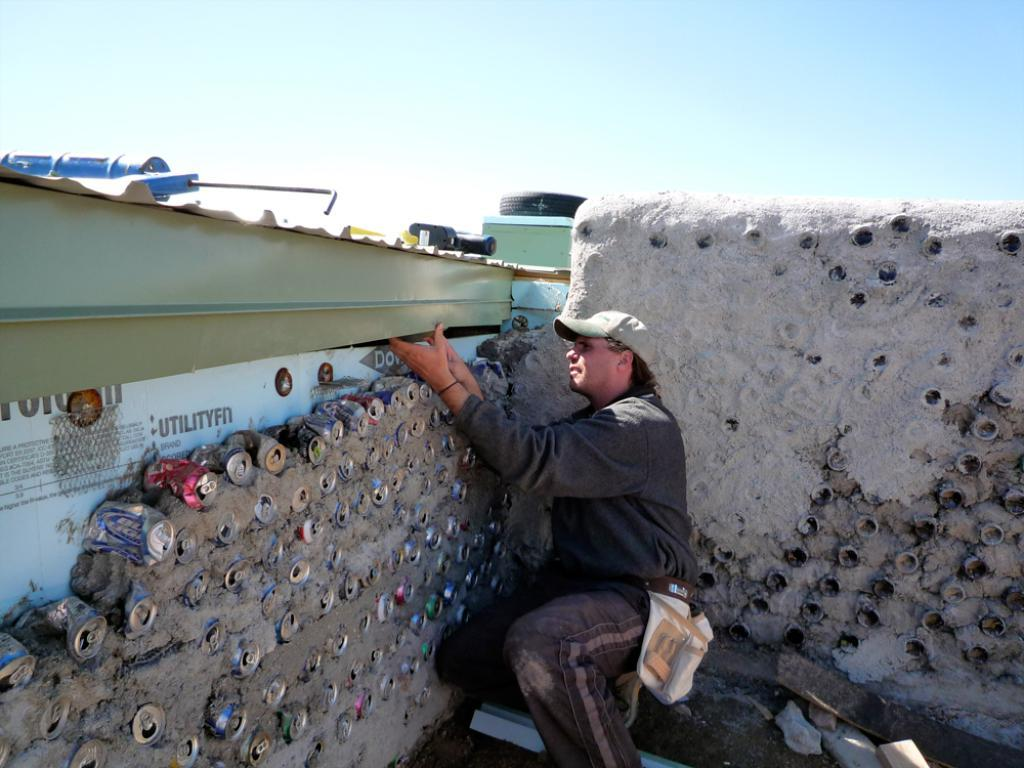What is the man in the image doing? The man is constructing a tin wall in the image. What can be seen in the background of the image? There is a bottle and a tire in the background of the image. How are the bottle and tire positioned in the background? The tire and bottle are placed on a box in the background of the image. What type of zipper can be seen on the man's clothing in the image? There is no zipper visible on the man's clothing in the image. What sound does the thunder make in the image? There is no thunder present in the image; it is a man constructing a tin wall with a bottle and tire in the background. 